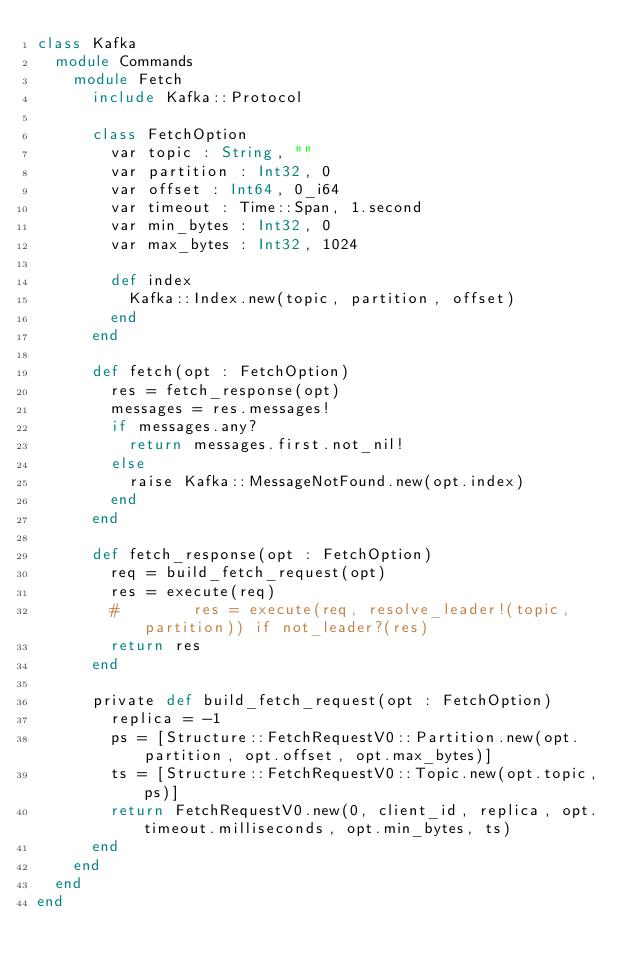<code> <loc_0><loc_0><loc_500><loc_500><_Crystal_>class Kafka
  module Commands
    module Fetch
      include Kafka::Protocol

      class FetchOption
        var topic : String, ""
        var partition : Int32, 0
        var offset : Int64, 0_i64
        var timeout : Time::Span, 1.second
        var min_bytes : Int32, 0
        var max_bytes : Int32, 1024

        def index
          Kafka::Index.new(topic, partition, offset)
        end
      end

      def fetch(opt : FetchOption)
        res = fetch_response(opt)
        messages = res.messages!
        if messages.any?
          return messages.first.not_nil!
        else
          raise Kafka::MessageNotFound.new(opt.index)
        end
      end

      def fetch_response(opt : FetchOption)
        req = build_fetch_request(opt)
        res = execute(req)
        #        res = execute(req, resolve_leader!(topic, partition)) if not_leader?(res)
        return res
      end

      private def build_fetch_request(opt : FetchOption)
        replica = -1
        ps = [Structure::FetchRequestV0::Partition.new(opt.partition, opt.offset, opt.max_bytes)]
        ts = [Structure::FetchRequestV0::Topic.new(opt.topic, ps)]
        return FetchRequestV0.new(0, client_id, replica, opt.timeout.milliseconds, opt.min_bytes, ts)
      end
    end
  end
end
</code> 